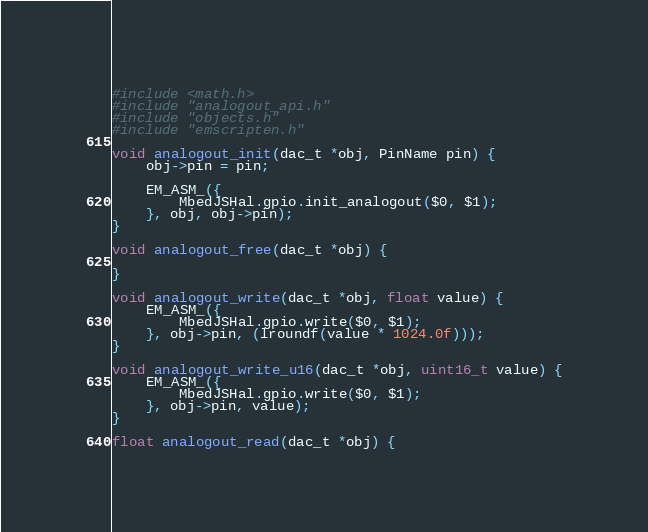Convert code to text. <code><loc_0><loc_0><loc_500><loc_500><_C_>#include <math.h>
#include "analogout_api.h"
#include "objects.h"
#include "emscripten.h"

void analogout_init(dac_t *obj, PinName pin) {
    obj->pin = pin;

    EM_ASM_({
        MbedJSHal.gpio.init_analogout($0, $1);
    }, obj, obj->pin);
}

void analogout_free(dac_t *obj) {

}

void analogout_write(dac_t *obj, float value) {
    EM_ASM_({
        MbedJSHal.gpio.write($0, $1);
    }, obj->pin, (lroundf(value * 1024.0f)));
}

void analogout_write_u16(dac_t *obj, uint16_t value) {
    EM_ASM_({
        MbedJSHal.gpio.write($0, $1);
    }, obj->pin, value);
}

float analogout_read(dac_t *obj) {</code> 